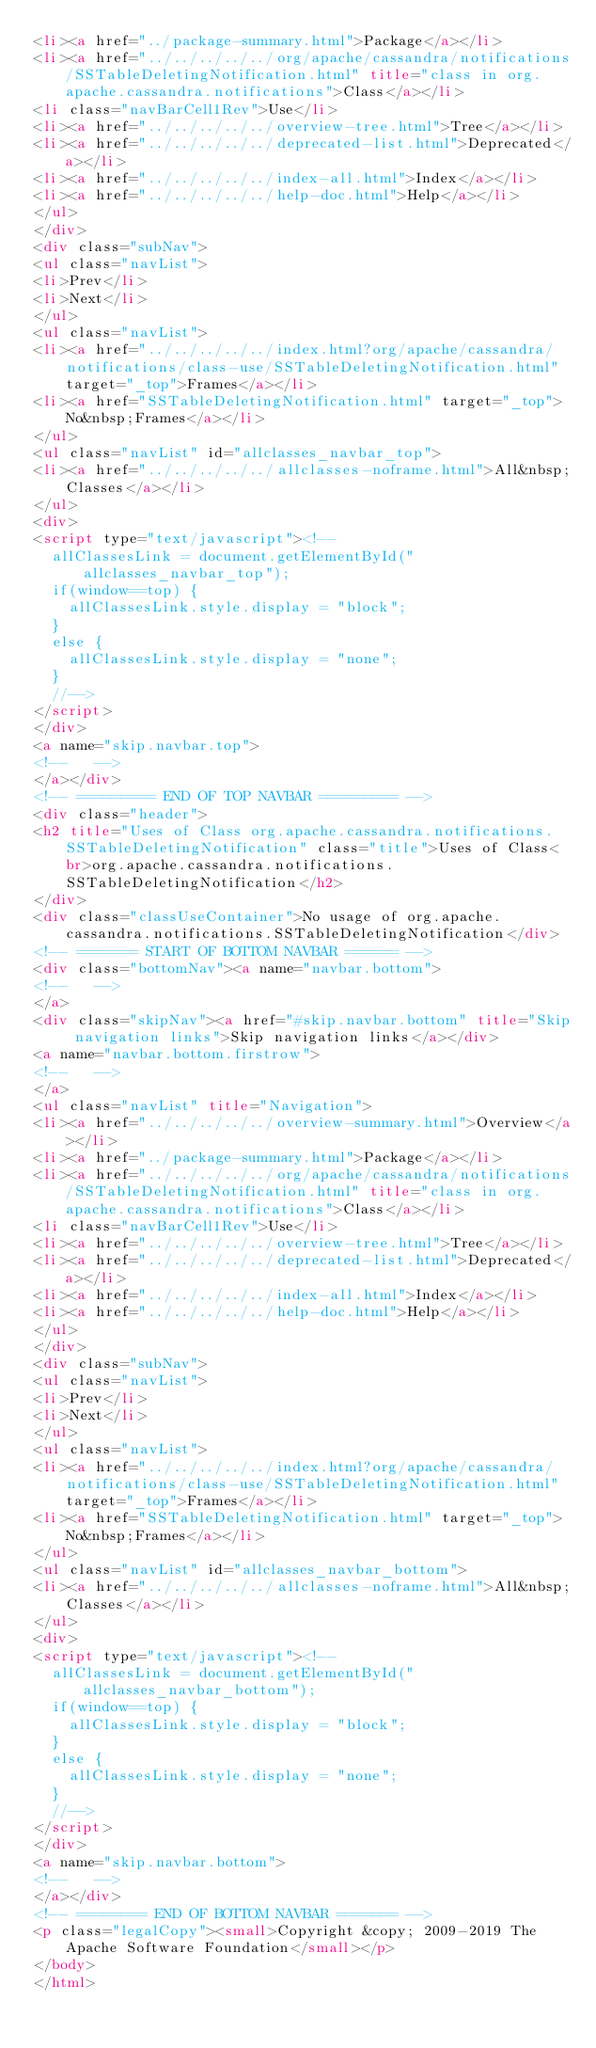Convert code to text. <code><loc_0><loc_0><loc_500><loc_500><_HTML_><li><a href="../package-summary.html">Package</a></li>
<li><a href="../../../../../org/apache/cassandra/notifications/SSTableDeletingNotification.html" title="class in org.apache.cassandra.notifications">Class</a></li>
<li class="navBarCell1Rev">Use</li>
<li><a href="../../../../../overview-tree.html">Tree</a></li>
<li><a href="../../../../../deprecated-list.html">Deprecated</a></li>
<li><a href="../../../../../index-all.html">Index</a></li>
<li><a href="../../../../../help-doc.html">Help</a></li>
</ul>
</div>
<div class="subNav">
<ul class="navList">
<li>Prev</li>
<li>Next</li>
</ul>
<ul class="navList">
<li><a href="../../../../../index.html?org/apache/cassandra/notifications/class-use/SSTableDeletingNotification.html" target="_top">Frames</a></li>
<li><a href="SSTableDeletingNotification.html" target="_top">No&nbsp;Frames</a></li>
</ul>
<ul class="navList" id="allclasses_navbar_top">
<li><a href="../../../../../allclasses-noframe.html">All&nbsp;Classes</a></li>
</ul>
<div>
<script type="text/javascript"><!--
  allClassesLink = document.getElementById("allclasses_navbar_top");
  if(window==top) {
    allClassesLink.style.display = "block";
  }
  else {
    allClassesLink.style.display = "none";
  }
  //-->
</script>
</div>
<a name="skip.navbar.top">
<!--   -->
</a></div>
<!-- ========= END OF TOP NAVBAR ========= -->
<div class="header">
<h2 title="Uses of Class org.apache.cassandra.notifications.SSTableDeletingNotification" class="title">Uses of Class<br>org.apache.cassandra.notifications.SSTableDeletingNotification</h2>
</div>
<div class="classUseContainer">No usage of org.apache.cassandra.notifications.SSTableDeletingNotification</div>
<!-- ======= START OF BOTTOM NAVBAR ====== -->
<div class="bottomNav"><a name="navbar.bottom">
<!--   -->
</a>
<div class="skipNav"><a href="#skip.navbar.bottom" title="Skip navigation links">Skip navigation links</a></div>
<a name="navbar.bottom.firstrow">
<!--   -->
</a>
<ul class="navList" title="Navigation">
<li><a href="../../../../../overview-summary.html">Overview</a></li>
<li><a href="../package-summary.html">Package</a></li>
<li><a href="../../../../../org/apache/cassandra/notifications/SSTableDeletingNotification.html" title="class in org.apache.cassandra.notifications">Class</a></li>
<li class="navBarCell1Rev">Use</li>
<li><a href="../../../../../overview-tree.html">Tree</a></li>
<li><a href="../../../../../deprecated-list.html">Deprecated</a></li>
<li><a href="../../../../../index-all.html">Index</a></li>
<li><a href="../../../../../help-doc.html">Help</a></li>
</ul>
</div>
<div class="subNav">
<ul class="navList">
<li>Prev</li>
<li>Next</li>
</ul>
<ul class="navList">
<li><a href="../../../../../index.html?org/apache/cassandra/notifications/class-use/SSTableDeletingNotification.html" target="_top">Frames</a></li>
<li><a href="SSTableDeletingNotification.html" target="_top">No&nbsp;Frames</a></li>
</ul>
<ul class="navList" id="allclasses_navbar_bottom">
<li><a href="../../../../../allclasses-noframe.html">All&nbsp;Classes</a></li>
</ul>
<div>
<script type="text/javascript"><!--
  allClassesLink = document.getElementById("allclasses_navbar_bottom");
  if(window==top) {
    allClassesLink.style.display = "block";
  }
  else {
    allClassesLink.style.display = "none";
  }
  //-->
</script>
</div>
<a name="skip.navbar.bottom">
<!--   -->
</a></div>
<!-- ======== END OF BOTTOM NAVBAR ======= -->
<p class="legalCopy"><small>Copyright &copy; 2009-2019 The Apache Software Foundation</small></p>
</body>
</html>
</code> 